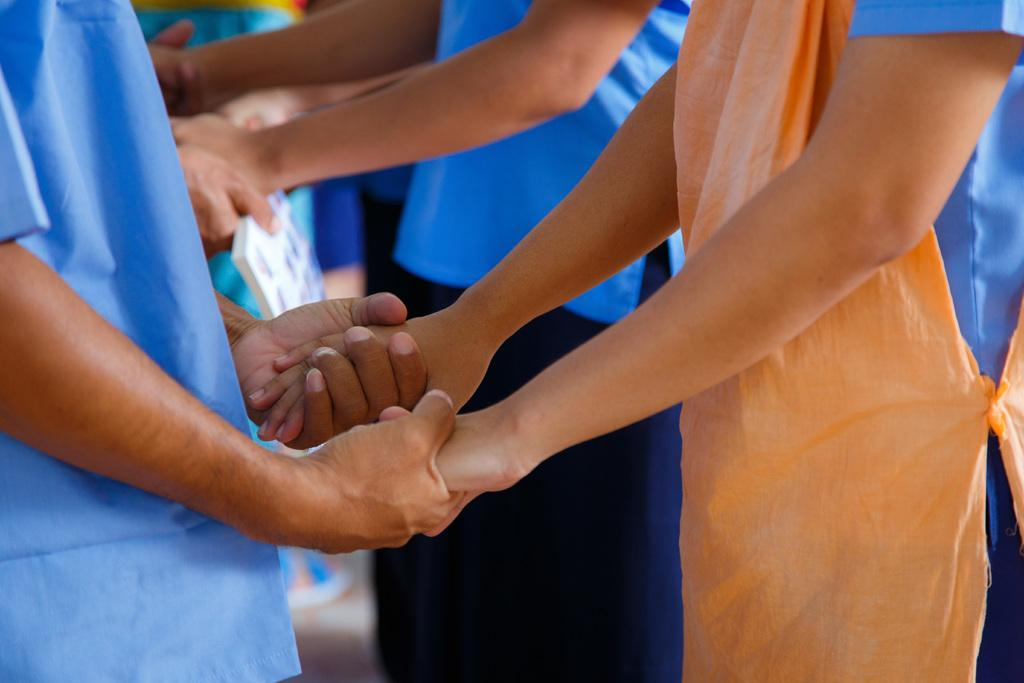How many people are in the image? There are people in the image, but the exact number is not specified. What are the people doing in the image? The people are holding each other's hands in the image. What type of sock is the person wearing on their left foot in the image? There is no information about socks or feet in the image, so it cannot be determined. 